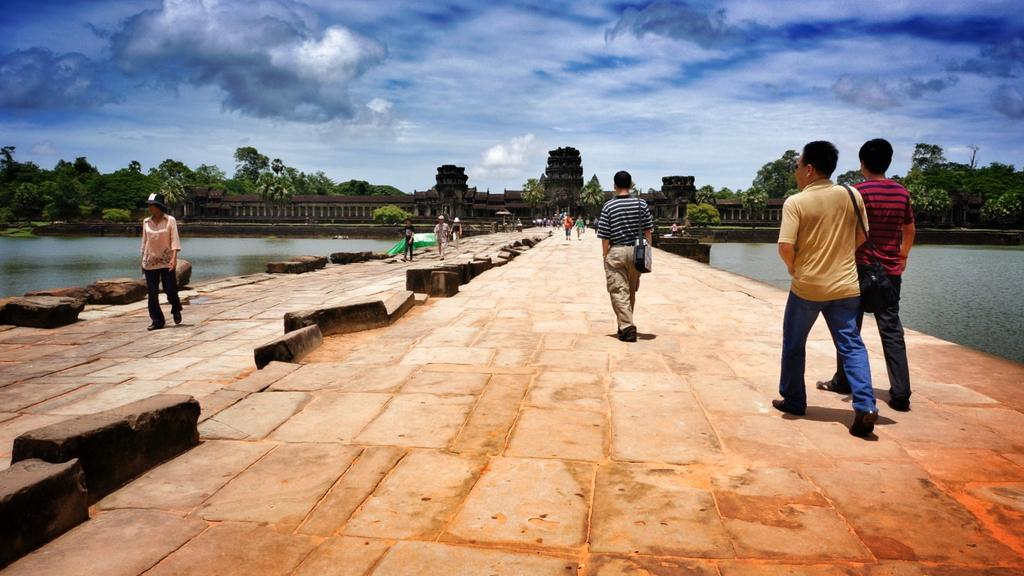What are the people in the image doing? There are persons on the floor in the image. What can be seen in the image besides the people? There is water visible in the image, as well as trees and a fort. What is visible in the background of the image? The sky is visible in the background of the image, with clouds present. What type of bait is being used by the persons on the stage in the image? There is no stage or bait present in the image; it features persons on the floor, water, trees, a fort, and a sky with clouds. 